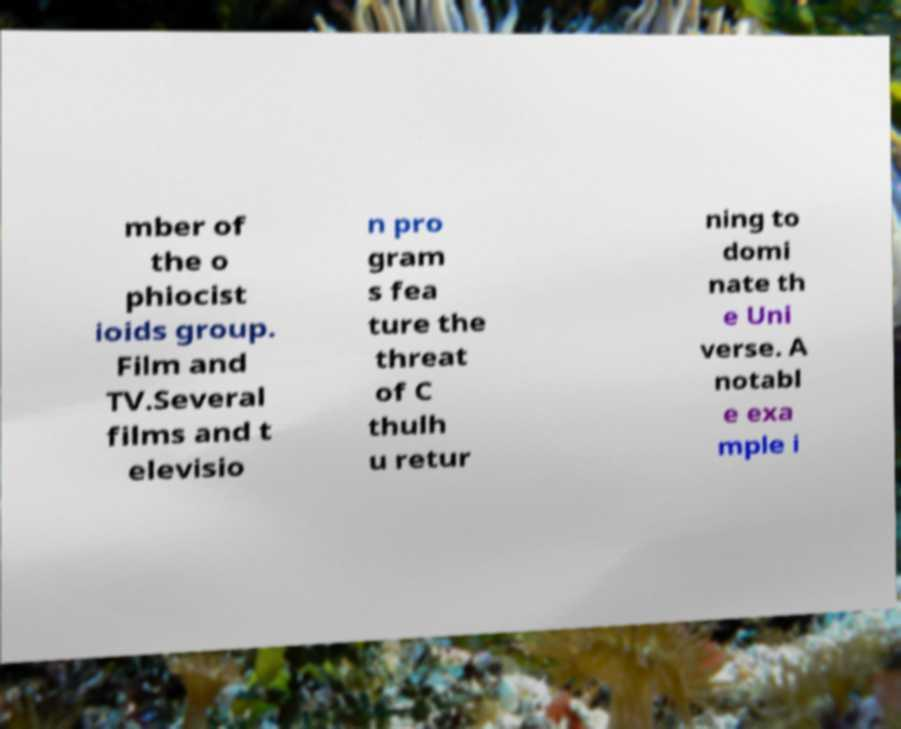There's text embedded in this image that I need extracted. Can you transcribe it verbatim? mber of the o phiocist ioids group. Film and TV.Several films and t elevisio n pro gram s fea ture the threat of C thulh u retur ning to domi nate th e Uni verse. A notabl e exa mple i 